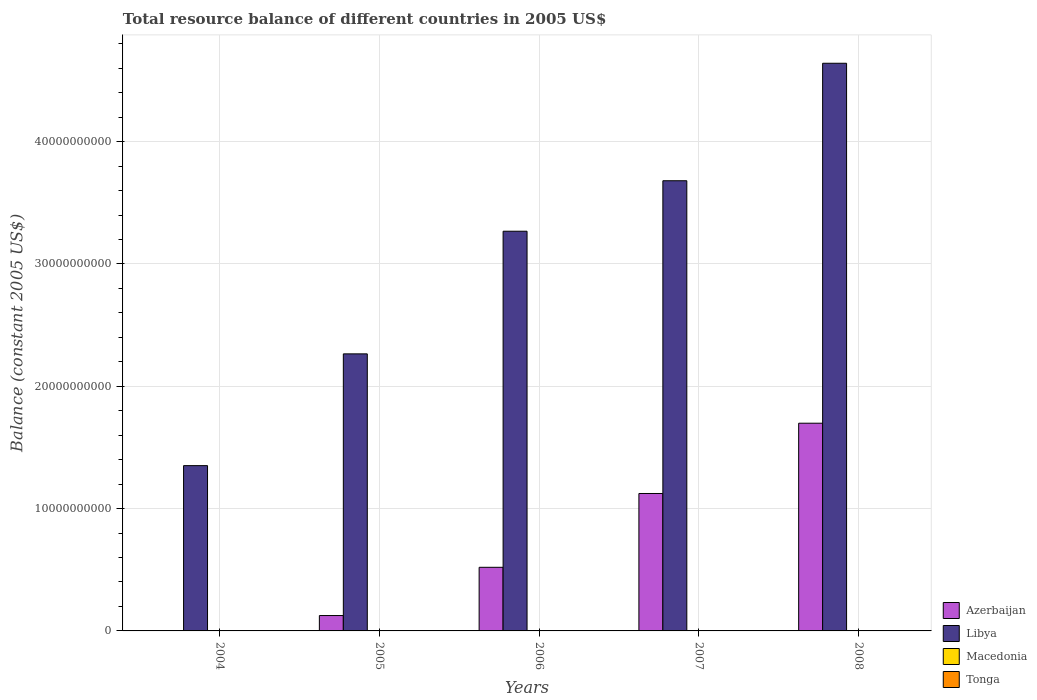How many different coloured bars are there?
Ensure brevity in your answer.  2. Are the number of bars on each tick of the X-axis equal?
Your answer should be compact. No. How many bars are there on the 1st tick from the right?
Keep it short and to the point. 2. What is the label of the 5th group of bars from the left?
Ensure brevity in your answer.  2008. In how many cases, is the number of bars for a given year not equal to the number of legend labels?
Your answer should be compact. 5. What is the total resource balance in Azerbaijan in 2005?
Ensure brevity in your answer.  1.26e+09. Across all years, what is the maximum total resource balance in Azerbaijan?
Offer a very short reply. 1.70e+1. Across all years, what is the minimum total resource balance in Libya?
Ensure brevity in your answer.  1.35e+1. What is the total total resource balance in Macedonia in the graph?
Your response must be concise. 0. What is the difference between the total resource balance in Libya in 2005 and that in 2008?
Make the answer very short. -2.38e+1. What is the difference between the total resource balance in Libya in 2007 and the total resource balance in Azerbaijan in 2005?
Keep it short and to the point. 3.55e+1. What is the average total resource balance in Azerbaijan per year?
Your answer should be very brief. 6.94e+09. In the year 2005, what is the difference between the total resource balance in Libya and total resource balance in Azerbaijan?
Your answer should be compact. 2.14e+1. In how many years, is the total resource balance in Tonga greater than 6000000000 US$?
Your answer should be compact. 0. What is the ratio of the total resource balance in Libya in 2004 to that in 2008?
Ensure brevity in your answer.  0.29. What is the difference between the highest and the second highest total resource balance in Libya?
Provide a short and direct response. 9.60e+09. What is the difference between the highest and the lowest total resource balance in Libya?
Keep it short and to the point. 3.29e+1. In how many years, is the total resource balance in Libya greater than the average total resource balance in Libya taken over all years?
Your response must be concise. 3. Is it the case that in every year, the sum of the total resource balance in Azerbaijan and total resource balance in Macedonia is greater than the sum of total resource balance in Tonga and total resource balance in Libya?
Offer a very short reply. No. How many bars are there?
Provide a succinct answer. 9. What is the difference between two consecutive major ticks on the Y-axis?
Offer a very short reply. 1.00e+1. Does the graph contain any zero values?
Provide a short and direct response. Yes. Where does the legend appear in the graph?
Make the answer very short. Bottom right. What is the title of the graph?
Ensure brevity in your answer.  Total resource balance of different countries in 2005 US$. Does "Turkmenistan" appear as one of the legend labels in the graph?
Ensure brevity in your answer.  No. What is the label or title of the X-axis?
Your answer should be compact. Years. What is the label or title of the Y-axis?
Your answer should be compact. Balance (constant 2005 US$). What is the Balance (constant 2005 US$) in Libya in 2004?
Your response must be concise. 1.35e+1. What is the Balance (constant 2005 US$) of Macedonia in 2004?
Keep it short and to the point. 0. What is the Balance (constant 2005 US$) in Tonga in 2004?
Give a very brief answer. 0. What is the Balance (constant 2005 US$) of Azerbaijan in 2005?
Keep it short and to the point. 1.26e+09. What is the Balance (constant 2005 US$) of Libya in 2005?
Offer a terse response. 2.27e+1. What is the Balance (constant 2005 US$) in Tonga in 2005?
Provide a short and direct response. 0. What is the Balance (constant 2005 US$) of Azerbaijan in 2006?
Provide a short and direct response. 5.20e+09. What is the Balance (constant 2005 US$) in Libya in 2006?
Your answer should be compact. 3.27e+1. What is the Balance (constant 2005 US$) of Macedonia in 2006?
Provide a short and direct response. 0. What is the Balance (constant 2005 US$) of Tonga in 2006?
Your answer should be very brief. 0. What is the Balance (constant 2005 US$) of Azerbaijan in 2007?
Your response must be concise. 1.12e+1. What is the Balance (constant 2005 US$) in Libya in 2007?
Provide a succinct answer. 3.68e+1. What is the Balance (constant 2005 US$) in Tonga in 2007?
Make the answer very short. 0. What is the Balance (constant 2005 US$) in Azerbaijan in 2008?
Provide a succinct answer. 1.70e+1. What is the Balance (constant 2005 US$) in Libya in 2008?
Your response must be concise. 4.64e+1. What is the Balance (constant 2005 US$) in Macedonia in 2008?
Ensure brevity in your answer.  0. Across all years, what is the maximum Balance (constant 2005 US$) in Azerbaijan?
Ensure brevity in your answer.  1.70e+1. Across all years, what is the maximum Balance (constant 2005 US$) in Libya?
Ensure brevity in your answer.  4.64e+1. Across all years, what is the minimum Balance (constant 2005 US$) of Libya?
Keep it short and to the point. 1.35e+1. What is the total Balance (constant 2005 US$) of Azerbaijan in the graph?
Your answer should be compact. 3.47e+1. What is the total Balance (constant 2005 US$) of Libya in the graph?
Your answer should be compact. 1.52e+11. What is the total Balance (constant 2005 US$) in Tonga in the graph?
Make the answer very short. 0. What is the difference between the Balance (constant 2005 US$) of Libya in 2004 and that in 2005?
Your answer should be compact. -9.14e+09. What is the difference between the Balance (constant 2005 US$) in Libya in 2004 and that in 2006?
Keep it short and to the point. -1.92e+1. What is the difference between the Balance (constant 2005 US$) in Libya in 2004 and that in 2007?
Ensure brevity in your answer.  -2.33e+1. What is the difference between the Balance (constant 2005 US$) of Libya in 2004 and that in 2008?
Offer a terse response. -3.29e+1. What is the difference between the Balance (constant 2005 US$) in Azerbaijan in 2005 and that in 2006?
Your response must be concise. -3.94e+09. What is the difference between the Balance (constant 2005 US$) in Libya in 2005 and that in 2006?
Give a very brief answer. -1.00e+1. What is the difference between the Balance (constant 2005 US$) in Azerbaijan in 2005 and that in 2007?
Keep it short and to the point. -9.98e+09. What is the difference between the Balance (constant 2005 US$) of Libya in 2005 and that in 2007?
Keep it short and to the point. -1.42e+1. What is the difference between the Balance (constant 2005 US$) in Azerbaijan in 2005 and that in 2008?
Keep it short and to the point. -1.57e+1. What is the difference between the Balance (constant 2005 US$) in Libya in 2005 and that in 2008?
Provide a succinct answer. -2.38e+1. What is the difference between the Balance (constant 2005 US$) in Azerbaijan in 2006 and that in 2007?
Ensure brevity in your answer.  -6.03e+09. What is the difference between the Balance (constant 2005 US$) in Libya in 2006 and that in 2007?
Offer a very short reply. -4.13e+09. What is the difference between the Balance (constant 2005 US$) in Azerbaijan in 2006 and that in 2008?
Ensure brevity in your answer.  -1.18e+1. What is the difference between the Balance (constant 2005 US$) of Libya in 2006 and that in 2008?
Make the answer very short. -1.37e+1. What is the difference between the Balance (constant 2005 US$) of Azerbaijan in 2007 and that in 2008?
Provide a short and direct response. -5.75e+09. What is the difference between the Balance (constant 2005 US$) in Libya in 2007 and that in 2008?
Give a very brief answer. -9.60e+09. What is the difference between the Balance (constant 2005 US$) of Azerbaijan in 2005 and the Balance (constant 2005 US$) of Libya in 2006?
Offer a very short reply. -3.14e+1. What is the difference between the Balance (constant 2005 US$) of Azerbaijan in 2005 and the Balance (constant 2005 US$) of Libya in 2007?
Provide a succinct answer. -3.55e+1. What is the difference between the Balance (constant 2005 US$) of Azerbaijan in 2005 and the Balance (constant 2005 US$) of Libya in 2008?
Offer a very short reply. -4.52e+1. What is the difference between the Balance (constant 2005 US$) of Azerbaijan in 2006 and the Balance (constant 2005 US$) of Libya in 2007?
Keep it short and to the point. -3.16e+1. What is the difference between the Balance (constant 2005 US$) in Azerbaijan in 2006 and the Balance (constant 2005 US$) in Libya in 2008?
Provide a short and direct response. -4.12e+1. What is the difference between the Balance (constant 2005 US$) in Azerbaijan in 2007 and the Balance (constant 2005 US$) in Libya in 2008?
Your answer should be compact. -3.52e+1. What is the average Balance (constant 2005 US$) in Azerbaijan per year?
Offer a terse response. 6.94e+09. What is the average Balance (constant 2005 US$) in Libya per year?
Your answer should be very brief. 3.04e+1. What is the average Balance (constant 2005 US$) in Macedonia per year?
Give a very brief answer. 0. In the year 2005, what is the difference between the Balance (constant 2005 US$) in Azerbaijan and Balance (constant 2005 US$) in Libya?
Give a very brief answer. -2.14e+1. In the year 2006, what is the difference between the Balance (constant 2005 US$) in Azerbaijan and Balance (constant 2005 US$) in Libya?
Your answer should be very brief. -2.75e+1. In the year 2007, what is the difference between the Balance (constant 2005 US$) of Azerbaijan and Balance (constant 2005 US$) of Libya?
Ensure brevity in your answer.  -2.56e+1. In the year 2008, what is the difference between the Balance (constant 2005 US$) of Azerbaijan and Balance (constant 2005 US$) of Libya?
Ensure brevity in your answer.  -2.94e+1. What is the ratio of the Balance (constant 2005 US$) in Libya in 2004 to that in 2005?
Your answer should be compact. 0.6. What is the ratio of the Balance (constant 2005 US$) of Libya in 2004 to that in 2006?
Make the answer very short. 0.41. What is the ratio of the Balance (constant 2005 US$) in Libya in 2004 to that in 2007?
Your response must be concise. 0.37. What is the ratio of the Balance (constant 2005 US$) of Libya in 2004 to that in 2008?
Make the answer very short. 0.29. What is the ratio of the Balance (constant 2005 US$) in Azerbaijan in 2005 to that in 2006?
Provide a succinct answer. 0.24. What is the ratio of the Balance (constant 2005 US$) of Libya in 2005 to that in 2006?
Make the answer very short. 0.69. What is the ratio of the Balance (constant 2005 US$) of Azerbaijan in 2005 to that in 2007?
Your answer should be very brief. 0.11. What is the ratio of the Balance (constant 2005 US$) of Libya in 2005 to that in 2007?
Provide a short and direct response. 0.62. What is the ratio of the Balance (constant 2005 US$) in Azerbaijan in 2005 to that in 2008?
Give a very brief answer. 0.07. What is the ratio of the Balance (constant 2005 US$) of Libya in 2005 to that in 2008?
Provide a short and direct response. 0.49. What is the ratio of the Balance (constant 2005 US$) in Azerbaijan in 2006 to that in 2007?
Provide a short and direct response. 0.46. What is the ratio of the Balance (constant 2005 US$) in Libya in 2006 to that in 2007?
Provide a short and direct response. 0.89. What is the ratio of the Balance (constant 2005 US$) of Azerbaijan in 2006 to that in 2008?
Make the answer very short. 0.31. What is the ratio of the Balance (constant 2005 US$) in Libya in 2006 to that in 2008?
Make the answer very short. 0.7. What is the ratio of the Balance (constant 2005 US$) of Azerbaijan in 2007 to that in 2008?
Your answer should be compact. 0.66. What is the ratio of the Balance (constant 2005 US$) of Libya in 2007 to that in 2008?
Your response must be concise. 0.79. What is the difference between the highest and the second highest Balance (constant 2005 US$) in Azerbaijan?
Your answer should be very brief. 5.75e+09. What is the difference between the highest and the second highest Balance (constant 2005 US$) of Libya?
Provide a short and direct response. 9.60e+09. What is the difference between the highest and the lowest Balance (constant 2005 US$) of Azerbaijan?
Provide a succinct answer. 1.70e+1. What is the difference between the highest and the lowest Balance (constant 2005 US$) in Libya?
Your answer should be very brief. 3.29e+1. 